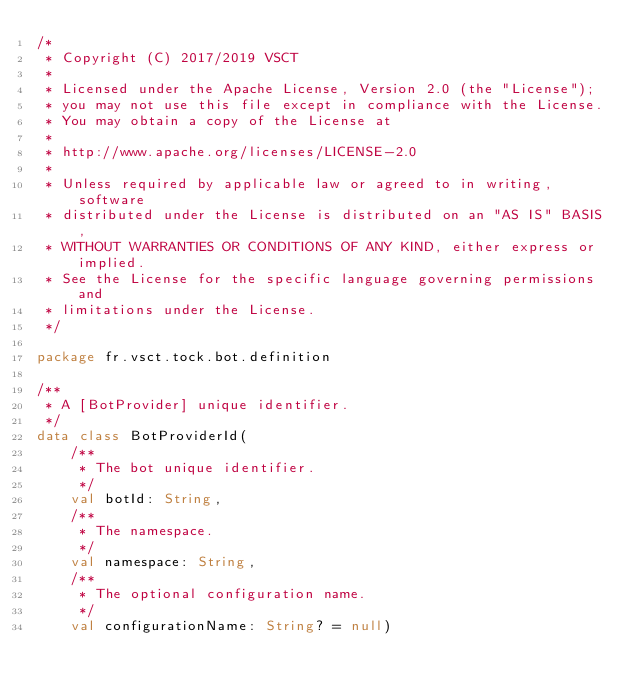Convert code to text. <code><loc_0><loc_0><loc_500><loc_500><_Kotlin_>/*
 * Copyright (C) 2017/2019 VSCT
 *
 * Licensed under the Apache License, Version 2.0 (the "License");
 * you may not use this file except in compliance with the License.
 * You may obtain a copy of the License at
 *
 * http://www.apache.org/licenses/LICENSE-2.0
 *
 * Unless required by applicable law or agreed to in writing, software
 * distributed under the License is distributed on an "AS IS" BASIS,
 * WITHOUT WARRANTIES OR CONDITIONS OF ANY KIND, either express or implied.
 * See the License for the specific language governing permissions and
 * limitations under the License.
 */

package fr.vsct.tock.bot.definition

/**
 * A [BotProvider] unique identifier.
 */
data class BotProviderId(
    /**
     * The bot unique identifier.
     */
    val botId: String,
    /**
     * The namespace.
     */
    val namespace: String,
    /**
     * The optional configuration name.
     */
    val configurationName: String? = null)</code> 